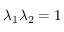<formula> <loc_0><loc_0><loc_500><loc_500>\lambda _ { 1 } \lambda _ { 2 } = 1</formula> 